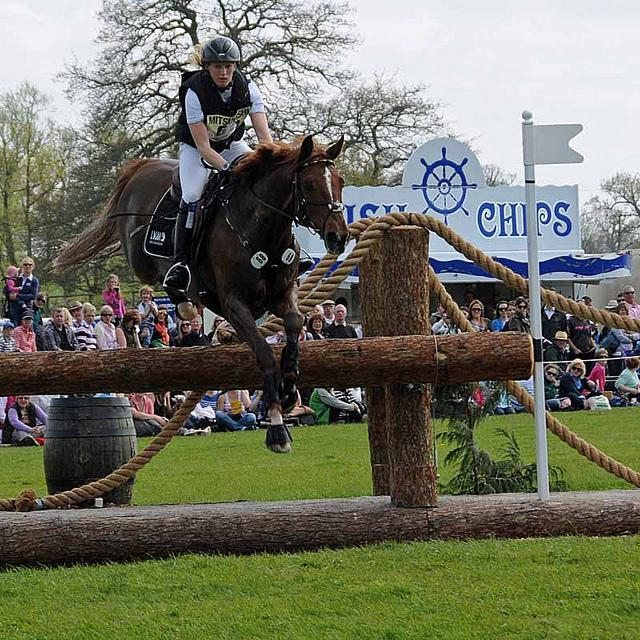What object is in the center of the chips stand logo? Please explain your reasoning. wheel. The object is located based on the text of the question and resembles a commonly known shape and identified by the circle with spokes around it. 